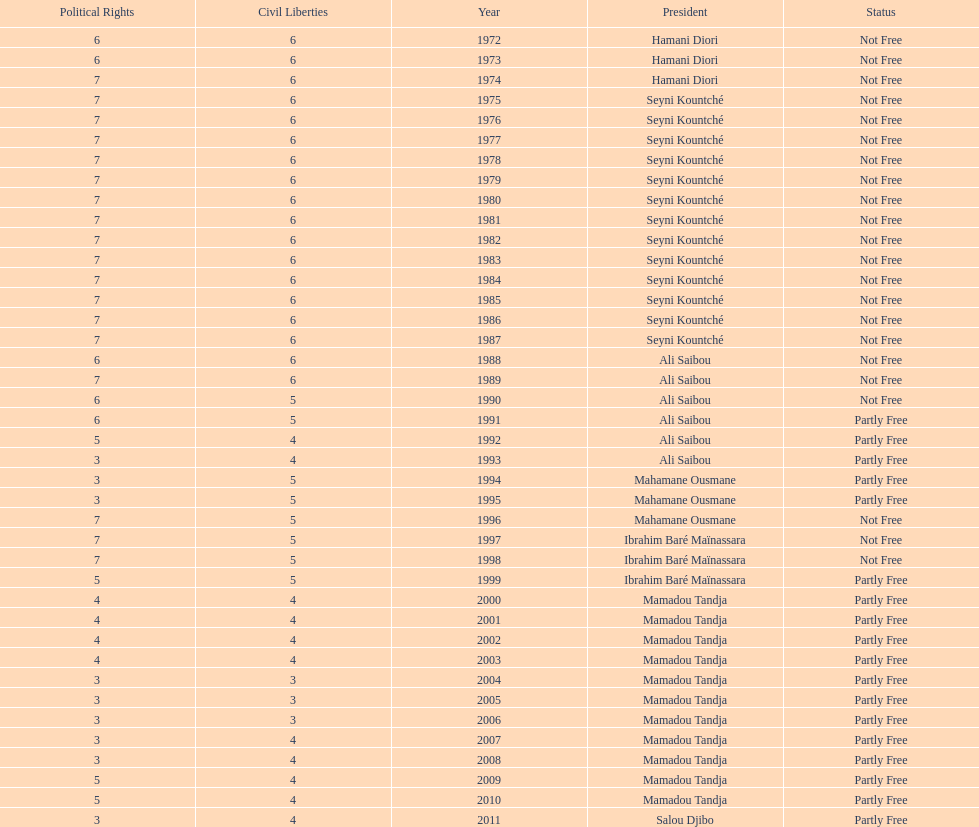Who ruled longer, ali saibou or mamadou tandja? Mamadou Tandja. 